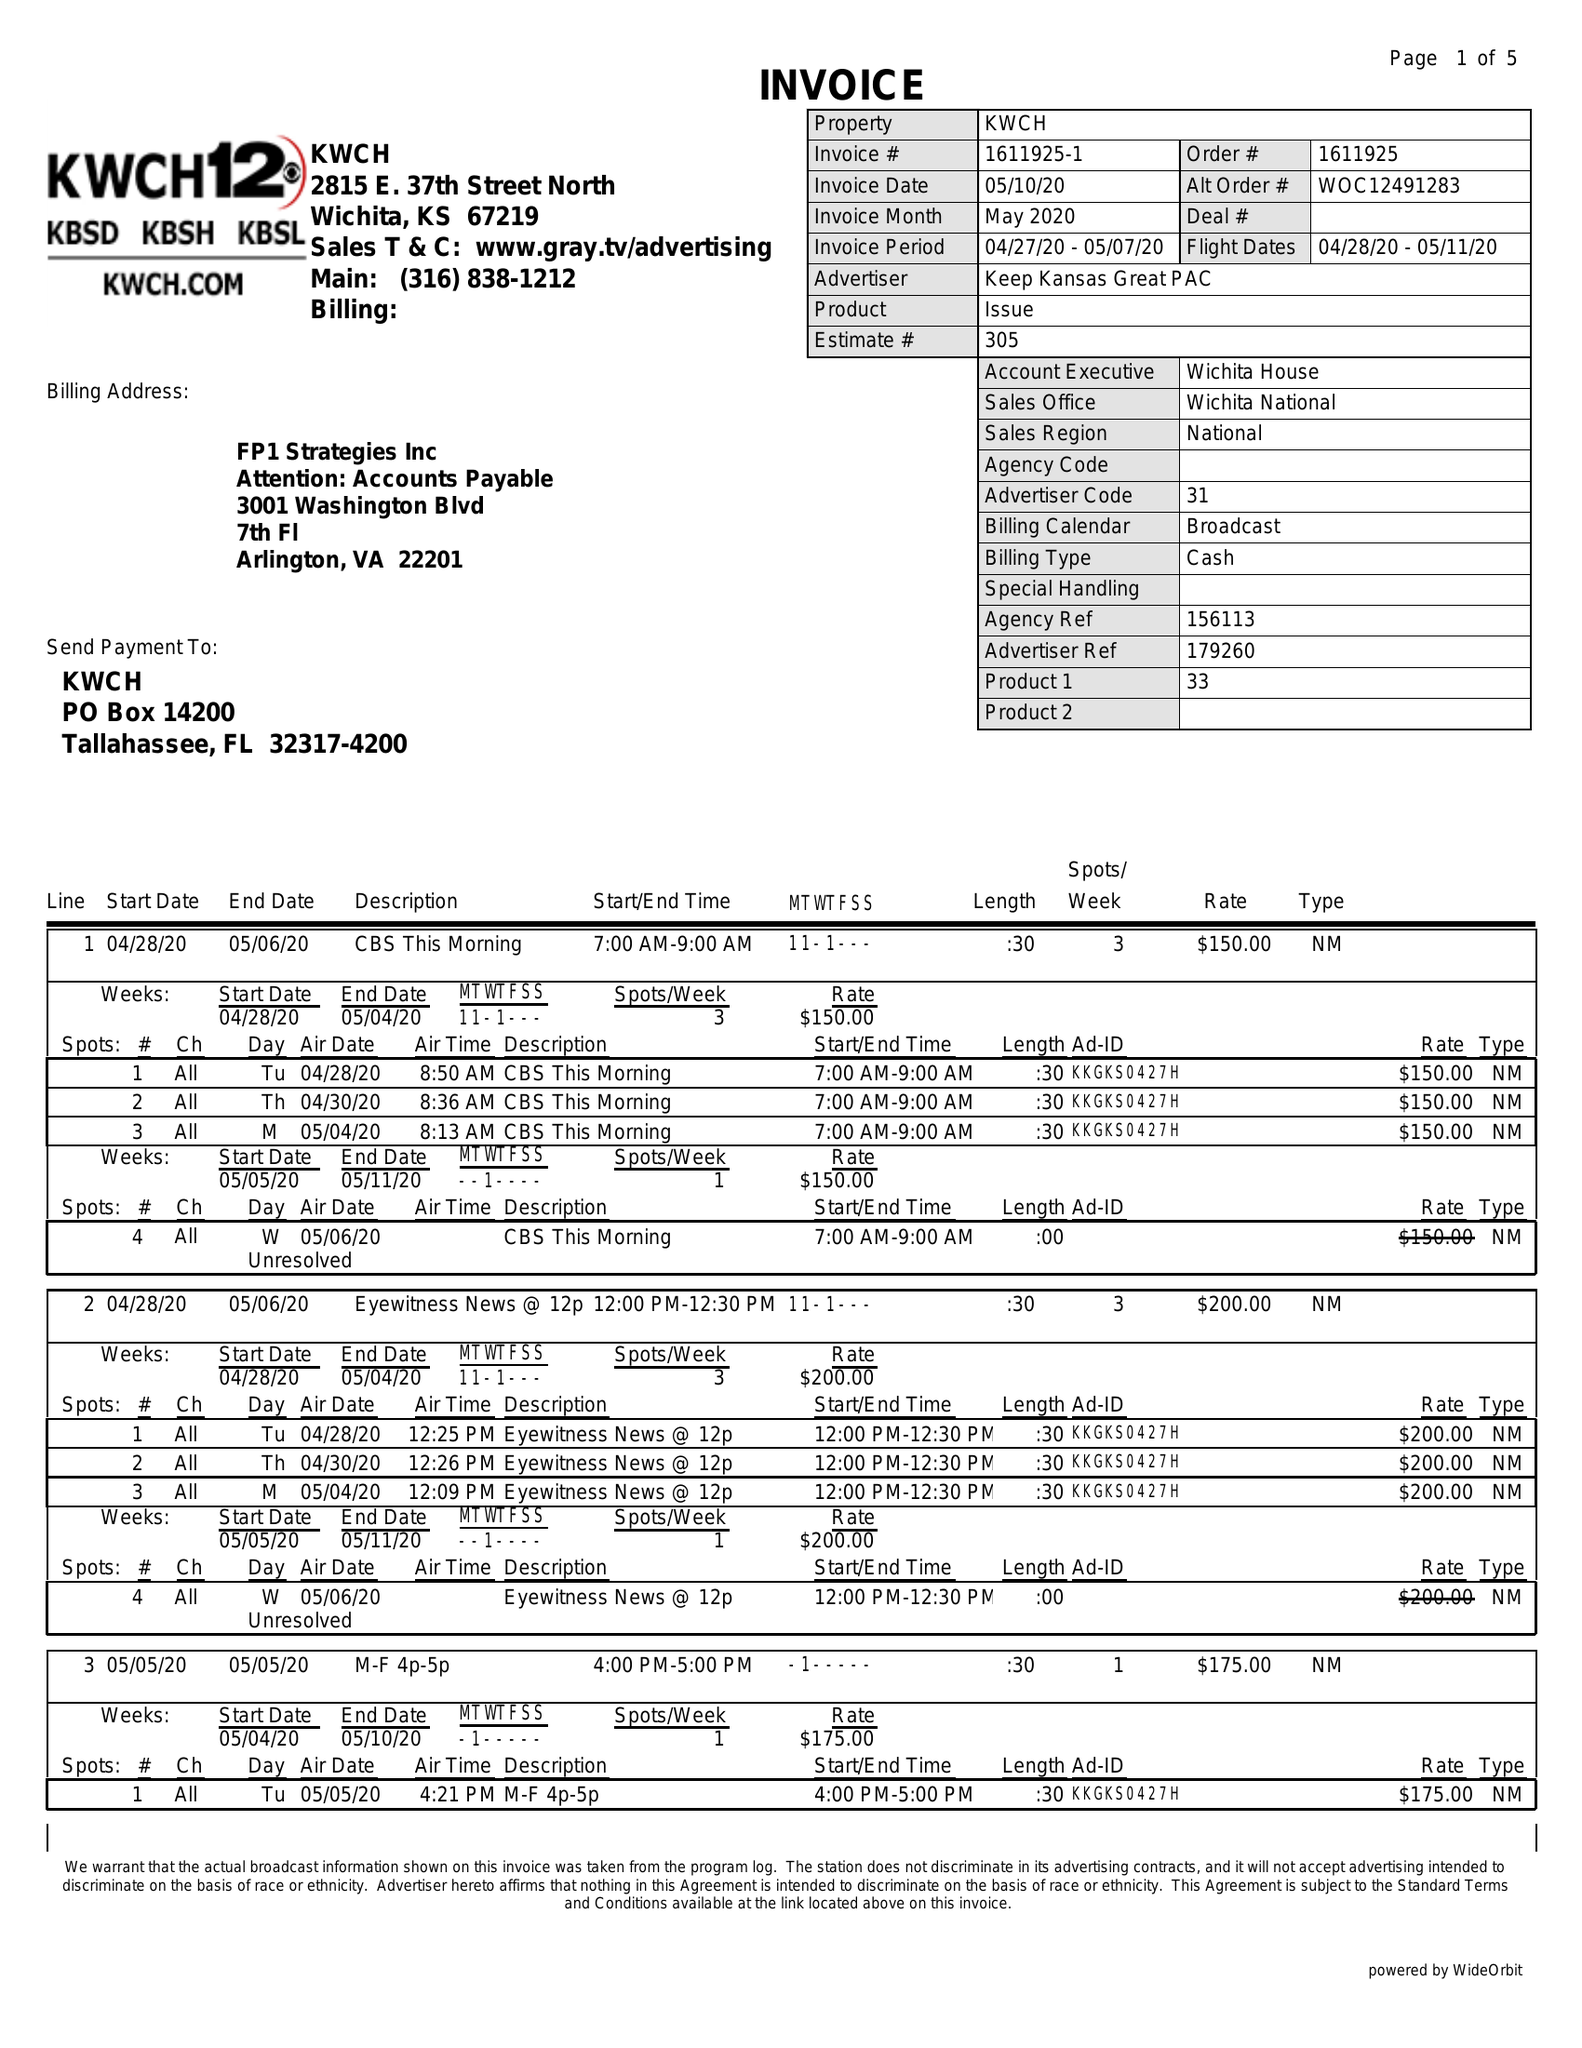What is the value for the advertiser?
Answer the question using a single word or phrase. KEEP KANSAS GREAT PAC 